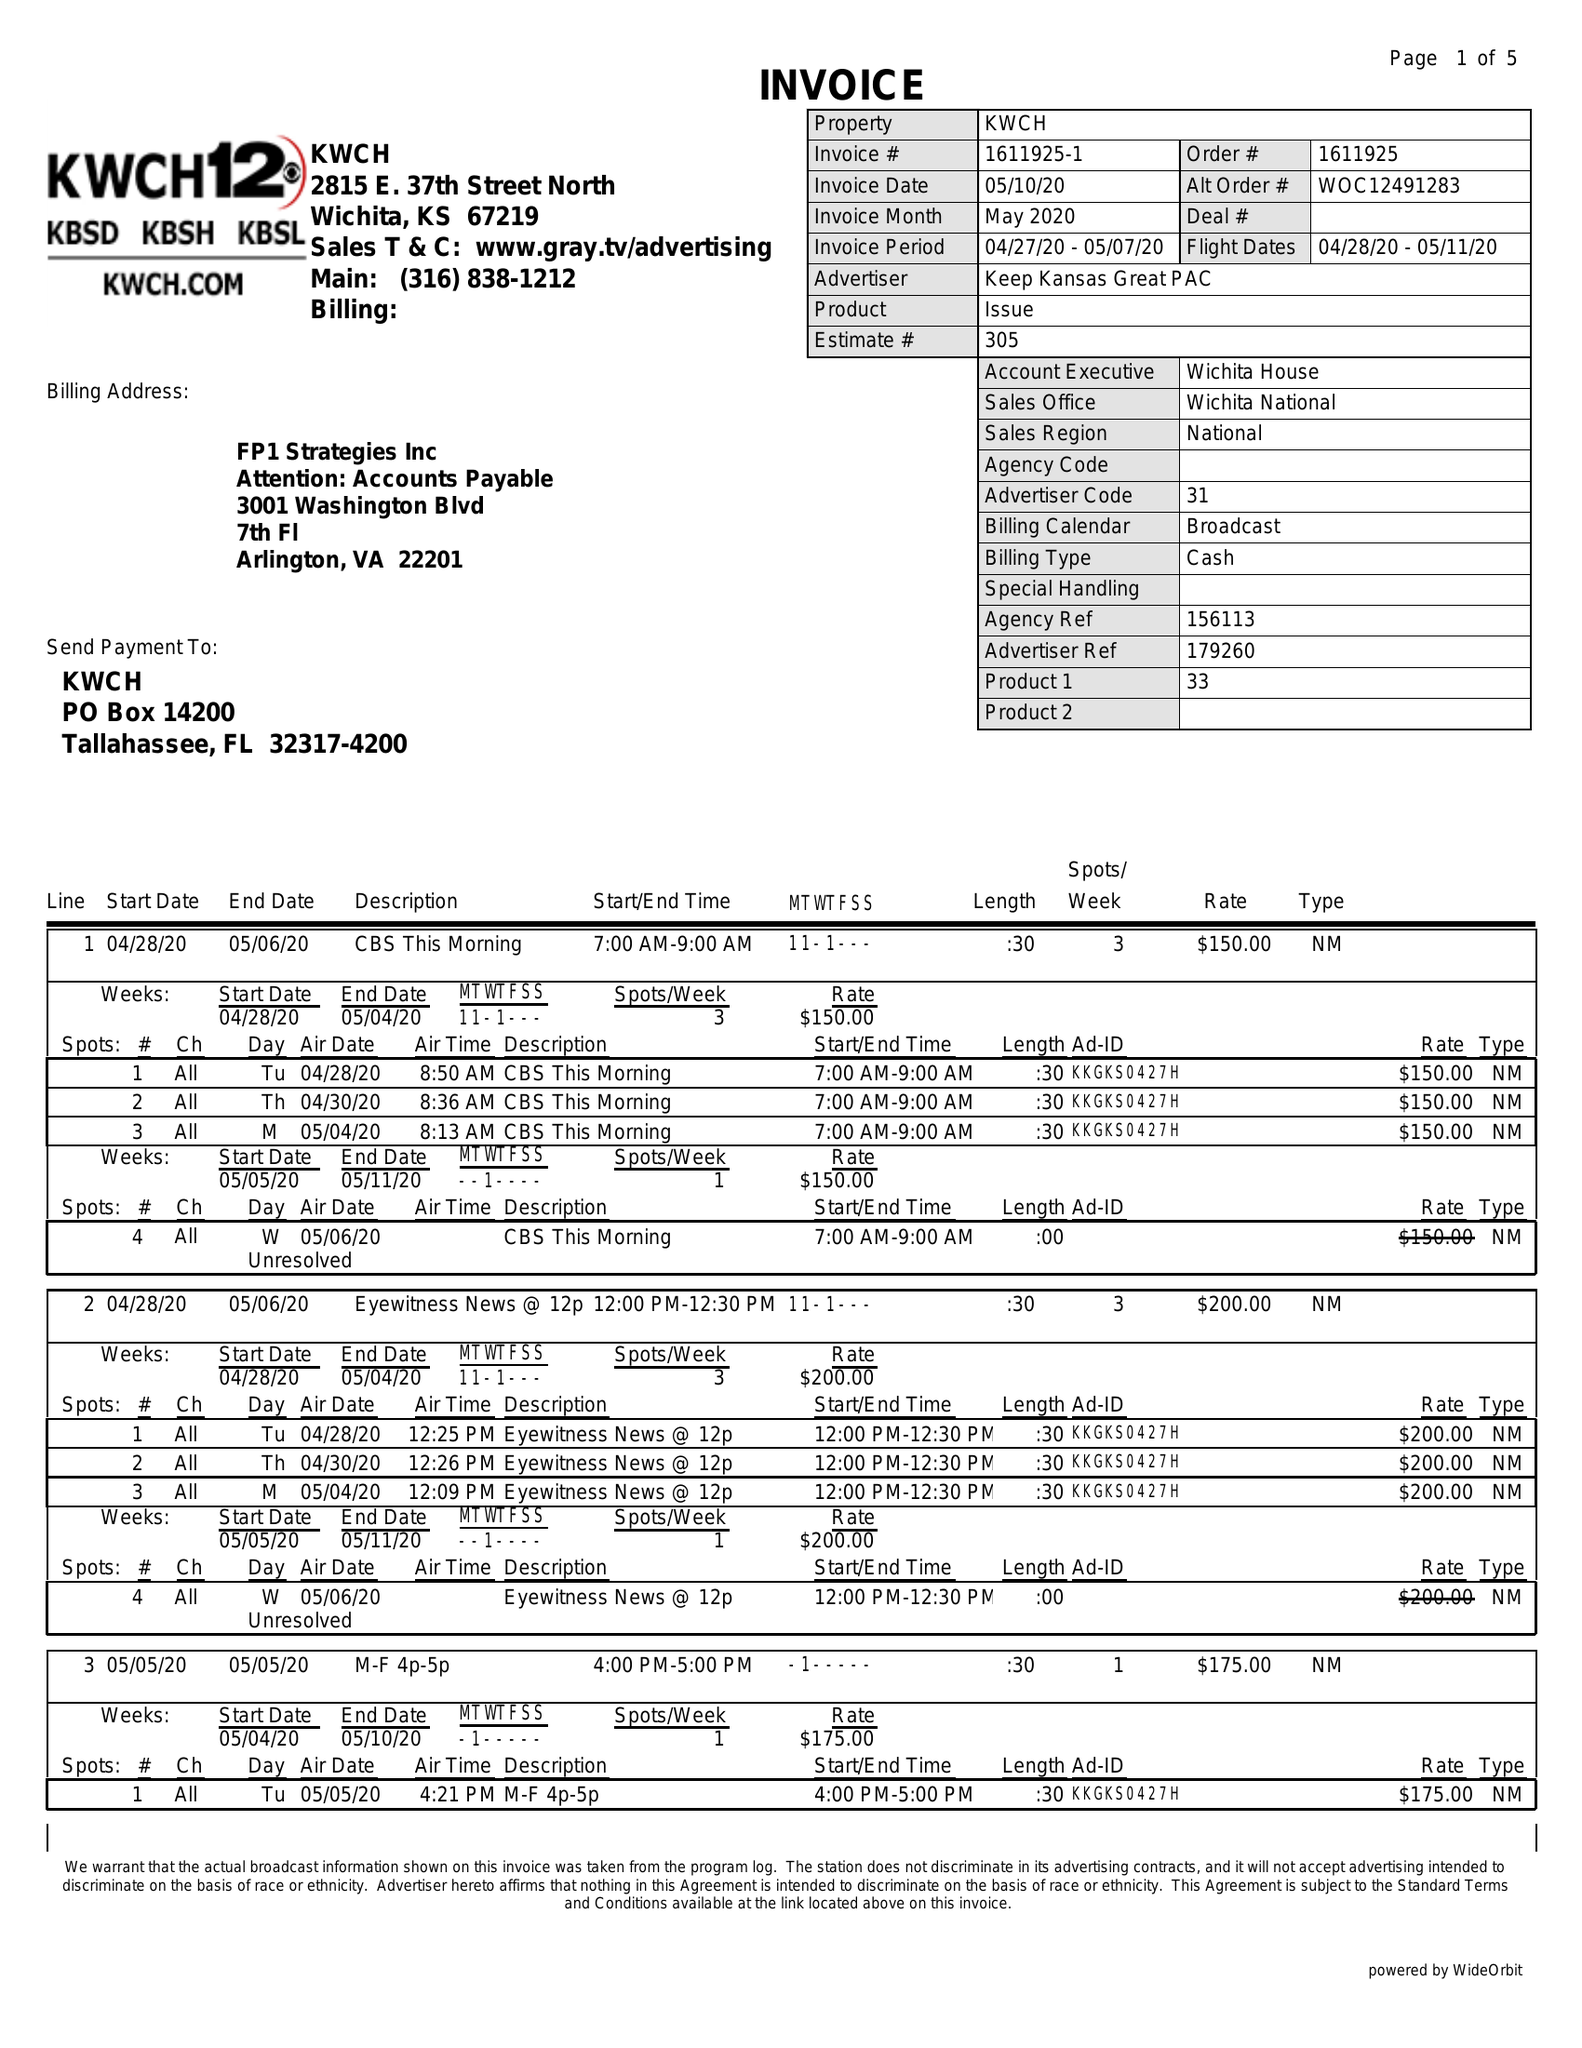What is the value for the advertiser?
Answer the question using a single word or phrase. KEEP KANSAS GREAT PAC 